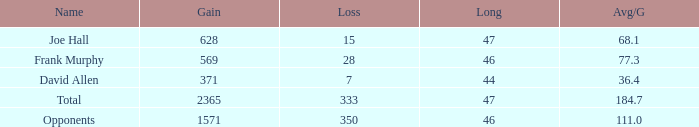What is the amount of loss with a gain less than 1571, a long less than 47, and an avg/g of 3 1.0. 